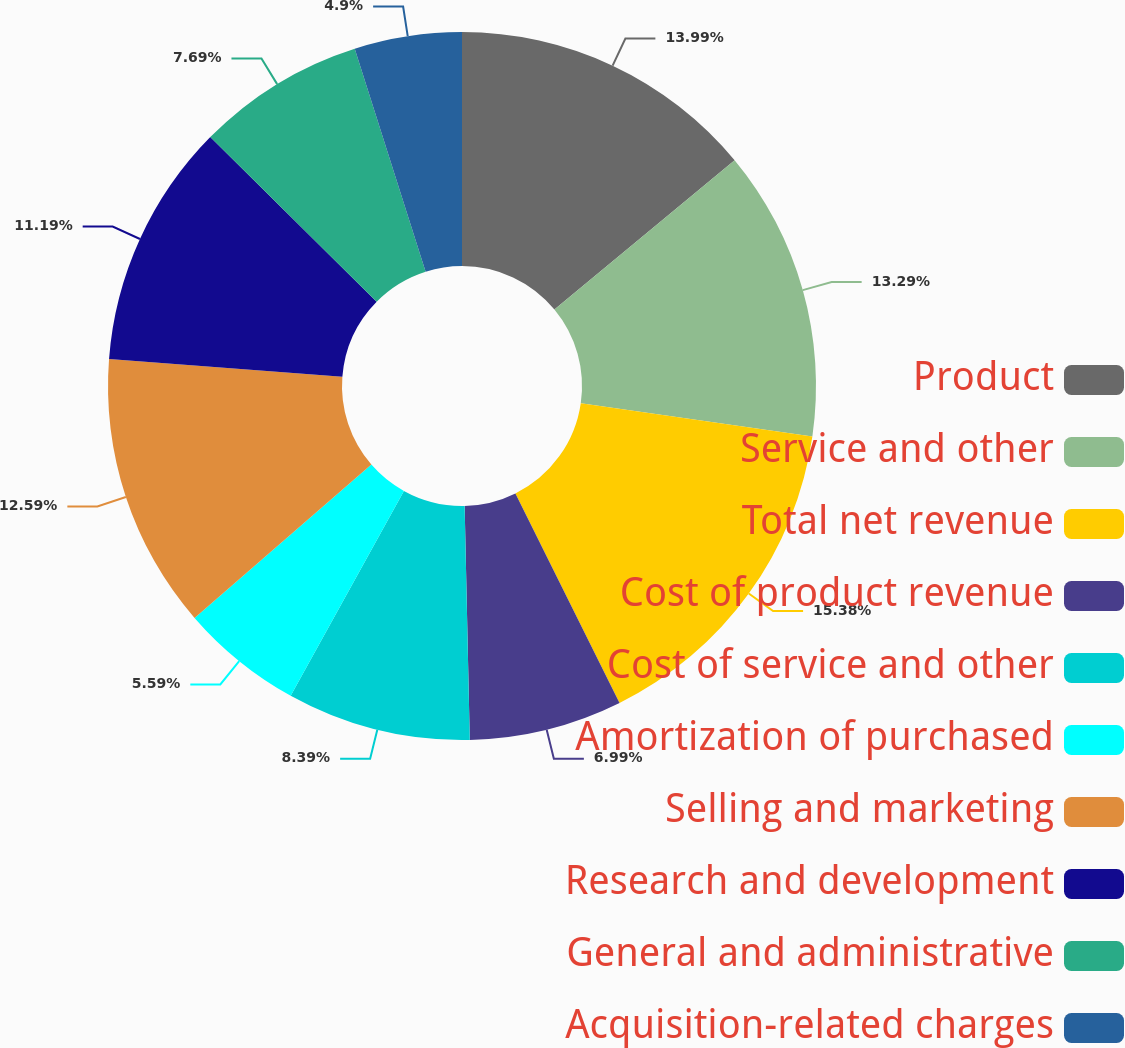Convert chart. <chart><loc_0><loc_0><loc_500><loc_500><pie_chart><fcel>Product<fcel>Service and other<fcel>Total net revenue<fcel>Cost of product revenue<fcel>Cost of service and other<fcel>Amortization of purchased<fcel>Selling and marketing<fcel>Research and development<fcel>General and administrative<fcel>Acquisition-related charges<nl><fcel>13.99%<fcel>13.29%<fcel>15.38%<fcel>6.99%<fcel>8.39%<fcel>5.59%<fcel>12.59%<fcel>11.19%<fcel>7.69%<fcel>4.9%<nl></chart> 